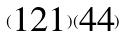<formula> <loc_0><loc_0><loc_500><loc_500>( \begin{matrix} 1 2 1 \end{matrix} ) ( \begin{matrix} 4 4 \end{matrix} )</formula> 